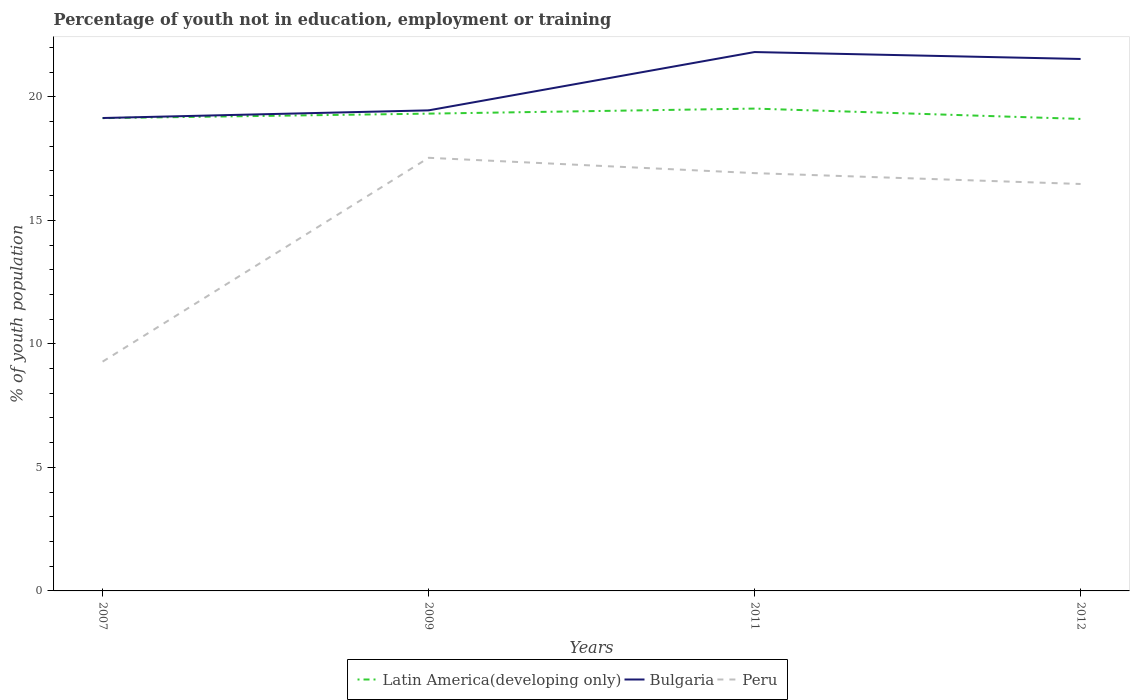Does the line corresponding to Latin America(developing only) intersect with the line corresponding to Peru?
Provide a short and direct response. No. Across all years, what is the maximum percentage of unemployed youth population in in Peru?
Your answer should be compact. 9.28. In which year was the percentage of unemployed youth population in in Peru maximum?
Give a very brief answer. 2007. What is the total percentage of unemployed youth population in in Peru in the graph?
Provide a short and direct response. -8.25. What is the difference between the highest and the second highest percentage of unemployed youth population in in Bulgaria?
Keep it short and to the point. 2.67. What is the difference between the highest and the lowest percentage of unemployed youth population in in Peru?
Offer a very short reply. 3. Is the percentage of unemployed youth population in in Latin America(developing only) strictly greater than the percentage of unemployed youth population in in Peru over the years?
Make the answer very short. No. How many lines are there?
Your answer should be very brief. 3. What is the difference between two consecutive major ticks on the Y-axis?
Keep it short and to the point. 5. Does the graph contain any zero values?
Your response must be concise. No. Does the graph contain grids?
Give a very brief answer. No. What is the title of the graph?
Offer a terse response. Percentage of youth not in education, employment or training. What is the label or title of the X-axis?
Provide a short and direct response. Years. What is the label or title of the Y-axis?
Give a very brief answer. % of youth population. What is the % of youth population in Latin America(developing only) in 2007?
Ensure brevity in your answer.  19.14. What is the % of youth population of Bulgaria in 2007?
Your answer should be very brief. 19.14. What is the % of youth population of Peru in 2007?
Offer a very short reply. 9.28. What is the % of youth population in Latin America(developing only) in 2009?
Your response must be concise. 19.32. What is the % of youth population in Bulgaria in 2009?
Keep it short and to the point. 19.45. What is the % of youth population of Peru in 2009?
Your response must be concise. 17.53. What is the % of youth population in Latin America(developing only) in 2011?
Keep it short and to the point. 19.52. What is the % of youth population of Bulgaria in 2011?
Provide a short and direct response. 21.81. What is the % of youth population in Peru in 2011?
Your answer should be very brief. 16.91. What is the % of youth population in Latin America(developing only) in 2012?
Provide a succinct answer. 19.1. What is the % of youth population of Bulgaria in 2012?
Keep it short and to the point. 21.53. What is the % of youth population of Peru in 2012?
Keep it short and to the point. 16.47. Across all years, what is the maximum % of youth population of Latin America(developing only)?
Offer a very short reply. 19.52. Across all years, what is the maximum % of youth population in Bulgaria?
Provide a succinct answer. 21.81. Across all years, what is the maximum % of youth population in Peru?
Ensure brevity in your answer.  17.53. Across all years, what is the minimum % of youth population of Latin America(developing only)?
Keep it short and to the point. 19.1. Across all years, what is the minimum % of youth population of Bulgaria?
Ensure brevity in your answer.  19.14. Across all years, what is the minimum % of youth population in Peru?
Provide a succinct answer. 9.28. What is the total % of youth population of Latin America(developing only) in the graph?
Your answer should be compact. 77.08. What is the total % of youth population in Bulgaria in the graph?
Provide a short and direct response. 81.93. What is the total % of youth population of Peru in the graph?
Make the answer very short. 60.19. What is the difference between the % of youth population in Latin America(developing only) in 2007 and that in 2009?
Provide a short and direct response. -0.18. What is the difference between the % of youth population in Bulgaria in 2007 and that in 2009?
Keep it short and to the point. -0.31. What is the difference between the % of youth population of Peru in 2007 and that in 2009?
Your answer should be compact. -8.25. What is the difference between the % of youth population of Latin America(developing only) in 2007 and that in 2011?
Your answer should be compact. -0.39. What is the difference between the % of youth population in Bulgaria in 2007 and that in 2011?
Ensure brevity in your answer.  -2.67. What is the difference between the % of youth population of Peru in 2007 and that in 2011?
Keep it short and to the point. -7.63. What is the difference between the % of youth population of Latin America(developing only) in 2007 and that in 2012?
Provide a succinct answer. 0.03. What is the difference between the % of youth population of Bulgaria in 2007 and that in 2012?
Ensure brevity in your answer.  -2.39. What is the difference between the % of youth population in Peru in 2007 and that in 2012?
Keep it short and to the point. -7.19. What is the difference between the % of youth population of Latin America(developing only) in 2009 and that in 2011?
Ensure brevity in your answer.  -0.2. What is the difference between the % of youth population of Bulgaria in 2009 and that in 2011?
Your answer should be very brief. -2.36. What is the difference between the % of youth population in Peru in 2009 and that in 2011?
Your answer should be very brief. 0.62. What is the difference between the % of youth population of Latin America(developing only) in 2009 and that in 2012?
Offer a terse response. 0.21. What is the difference between the % of youth population in Bulgaria in 2009 and that in 2012?
Make the answer very short. -2.08. What is the difference between the % of youth population of Peru in 2009 and that in 2012?
Your answer should be very brief. 1.06. What is the difference between the % of youth population in Latin America(developing only) in 2011 and that in 2012?
Keep it short and to the point. 0.42. What is the difference between the % of youth population in Bulgaria in 2011 and that in 2012?
Ensure brevity in your answer.  0.28. What is the difference between the % of youth population in Peru in 2011 and that in 2012?
Offer a very short reply. 0.44. What is the difference between the % of youth population of Latin America(developing only) in 2007 and the % of youth population of Bulgaria in 2009?
Make the answer very short. -0.31. What is the difference between the % of youth population in Latin America(developing only) in 2007 and the % of youth population in Peru in 2009?
Your answer should be compact. 1.61. What is the difference between the % of youth population in Bulgaria in 2007 and the % of youth population in Peru in 2009?
Offer a very short reply. 1.61. What is the difference between the % of youth population of Latin America(developing only) in 2007 and the % of youth population of Bulgaria in 2011?
Offer a very short reply. -2.67. What is the difference between the % of youth population of Latin America(developing only) in 2007 and the % of youth population of Peru in 2011?
Give a very brief answer. 2.23. What is the difference between the % of youth population in Bulgaria in 2007 and the % of youth population in Peru in 2011?
Offer a terse response. 2.23. What is the difference between the % of youth population of Latin America(developing only) in 2007 and the % of youth population of Bulgaria in 2012?
Keep it short and to the point. -2.39. What is the difference between the % of youth population of Latin America(developing only) in 2007 and the % of youth population of Peru in 2012?
Provide a succinct answer. 2.67. What is the difference between the % of youth population of Bulgaria in 2007 and the % of youth population of Peru in 2012?
Provide a short and direct response. 2.67. What is the difference between the % of youth population in Latin America(developing only) in 2009 and the % of youth population in Bulgaria in 2011?
Offer a very short reply. -2.49. What is the difference between the % of youth population in Latin America(developing only) in 2009 and the % of youth population in Peru in 2011?
Keep it short and to the point. 2.41. What is the difference between the % of youth population of Bulgaria in 2009 and the % of youth population of Peru in 2011?
Ensure brevity in your answer.  2.54. What is the difference between the % of youth population in Latin America(developing only) in 2009 and the % of youth population in Bulgaria in 2012?
Keep it short and to the point. -2.21. What is the difference between the % of youth population in Latin America(developing only) in 2009 and the % of youth population in Peru in 2012?
Provide a short and direct response. 2.85. What is the difference between the % of youth population of Bulgaria in 2009 and the % of youth population of Peru in 2012?
Ensure brevity in your answer.  2.98. What is the difference between the % of youth population in Latin America(developing only) in 2011 and the % of youth population in Bulgaria in 2012?
Provide a short and direct response. -2.01. What is the difference between the % of youth population in Latin America(developing only) in 2011 and the % of youth population in Peru in 2012?
Offer a very short reply. 3.05. What is the difference between the % of youth population of Bulgaria in 2011 and the % of youth population of Peru in 2012?
Offer a terse response. 5.34. What is the average % of youth population of Latin America(developing only) per year?
Make the answer very short. 19.27. What is the average % of youth population in Bulgaria per year?
Your response must be concise. 20.48. What is the average % of youth population of Peru per year?
Make the answer very short. 15.05. In the year 2007, what is the difference between the % of youth population in Latin America(developing only) and % of youth population in Bulgaria?
Your response must be concise. -0. In the year 2007, what is the difference between the % of youth population of Latin America(developing only) and % of youth population of Peru?
Provide a succinct answer. 9.86. In the year 2007, what is the difference between the % of youth population in Bulgaria and % of youth population in Peru?
Make the answer very short. 9.86. In the year 2009, what is the difference between the % of youth population in Latin America(developing only) and % of youth population in Bulgaria?
Your answer should be compact. -0.13. In the year 2009, what is the difference between the % of youth population in Latin America(developing only) and % of youth population in Peru?
Make the answer very short. 1.79. In the year 2009, what is the difference between the % of youth population of Bulgaria and % of youth population of Peru?
Keep it short and to the point. 1.92. In the year 2011, what is the difference between the % of youth population in Latin America(developing only) and % of youth population in Bulgaria?
Provide a short and direct response. -2.29. In the year 2011, what is the difference between the % of youth population of Latin America(developing only) and % of youth population of Peru?
Provide a short and direct response. 2.61. In the year 2011, what is the difference between the % of youth population of Bulgaria and % of youth population of Peru?
Give a very brief answer. 4.9. In the year 2012, what is the difference between the % of youth population of Latin America(developing only) and % of youth population of Bulgaria?
Your response must be concise. -2.43. In the year 2012, what is the difference between the % of youth population in Latin America(developing only) and % of youth population in Peru?
Your answer should be very brief. 2.63. In the year 2012, what is the difference between the % of youth population in Bulgaria and % of youth population in Peru?
Provide a succinct answer. 5.06. What is the ratio of the % of youth population of Latin America(developing only) in 2007 to that in 2009?
Offer a very short reply. 0.99. What is the ratio of the % of youth population of Bulgaria in 2007 to that in 2009?
Offer a very short reply. 0.98. What is the ratio of the % of youth population in Peru in 2007 to that in 2009?
Your answer should be very brief. 0.53. What is the ratio of the % of youth population of Latin America(developing only) in 2007 to that in 2011?
Provide a short and direct response. 0.98. What is the ratio of the % of youth population in Bulgaria in 2007 to that in 2011?
Provide a short and direct response. 0.88. What is the ratio of the % of youth population in Peru in 2007 to that in 2011?
Keep it short and to the point. 0.55. What is the ratio of the % of youth population in Bulgaria in 2007 to that in 2012?
Your response must be concise. 0.89. What is the ratio of the % of youth population in Peru in 2007 to that in 2012?
Ensure brevity in your answer.  0.56. What is the ratio of the % of youth population in Bulgaria in 2009 to that in 2011?
Keep it short and to the point. 0.89. What is the ratio of the % of youth population in Peru in 2009 to that in 2011?
Offer a terse response. 1.04. What is the ratio of the % of youth population of Latin America(developing only) in 2009 to that in 2012?
Ensure brevity in your answer.  1.01. What is the ratio of the % of youth population of Bulgaria in 2009 to that in 2012?
Make the answer very short. 0.9. What is the ratio of the % of youth population in Peru in 2009 to that in 2012?
Give a very brief answer. 1.06. What is the ratio of the % of youth population in Latin America(developing only) in 2011 to that in 2012?
Give a very brief answer. 1.02. What is the ratio of the % of youth population in Bulgaria in 2011 to that in 2012?
Your answer should be compact. 1.01. What is the ratio of the % of youth population of Peru in 2011 to that in 2012?
Offer a very short reply. 1.03. What is the difference between the highest and the second highest % of youth population in Latin America(developing only)?
Give a very brief answer. 0.2. What is the difference between the highest and the second highest % of youth population in Bulgaria?
Make the answer very short. 0.28. What is the difference between the highest and the second highest % of youth population in Peru?
Give a very brief answer. 0.62. What is the difference between the highest and the lowest % of youth population of Latin America(developing only)?
Provide a succinct answer. 0.42. What is the difference between the highest and the lowest % of youth population of Bulgaria?
Provide a short and direct response. 2.67. What is the difference between the highest and the lowest % of youth population of Peru?
Offer a very short reply. 8.25. 